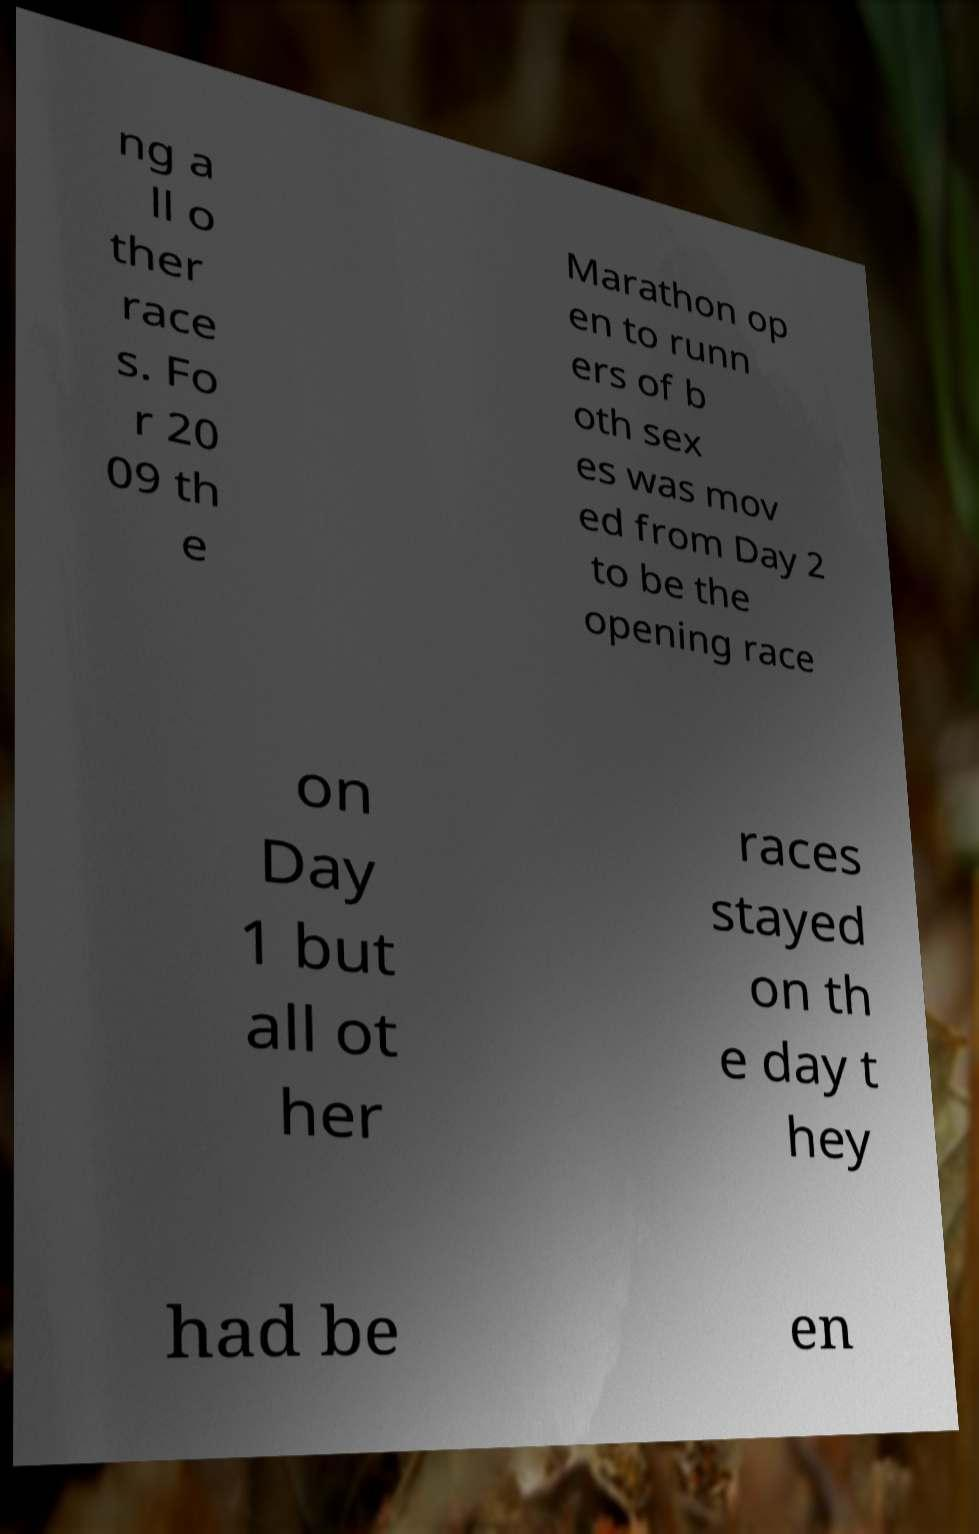There's text embedded in this image that I need extracted. Can you transcribe it verbatim? ng a ll o ther race s. Fo r 20 09 th e Marathon op en to runn ers of b oth sex es was mov ed from Day 2 to be the opening race on Day 1 but all ot her races stayed on th e day t hey had be en 